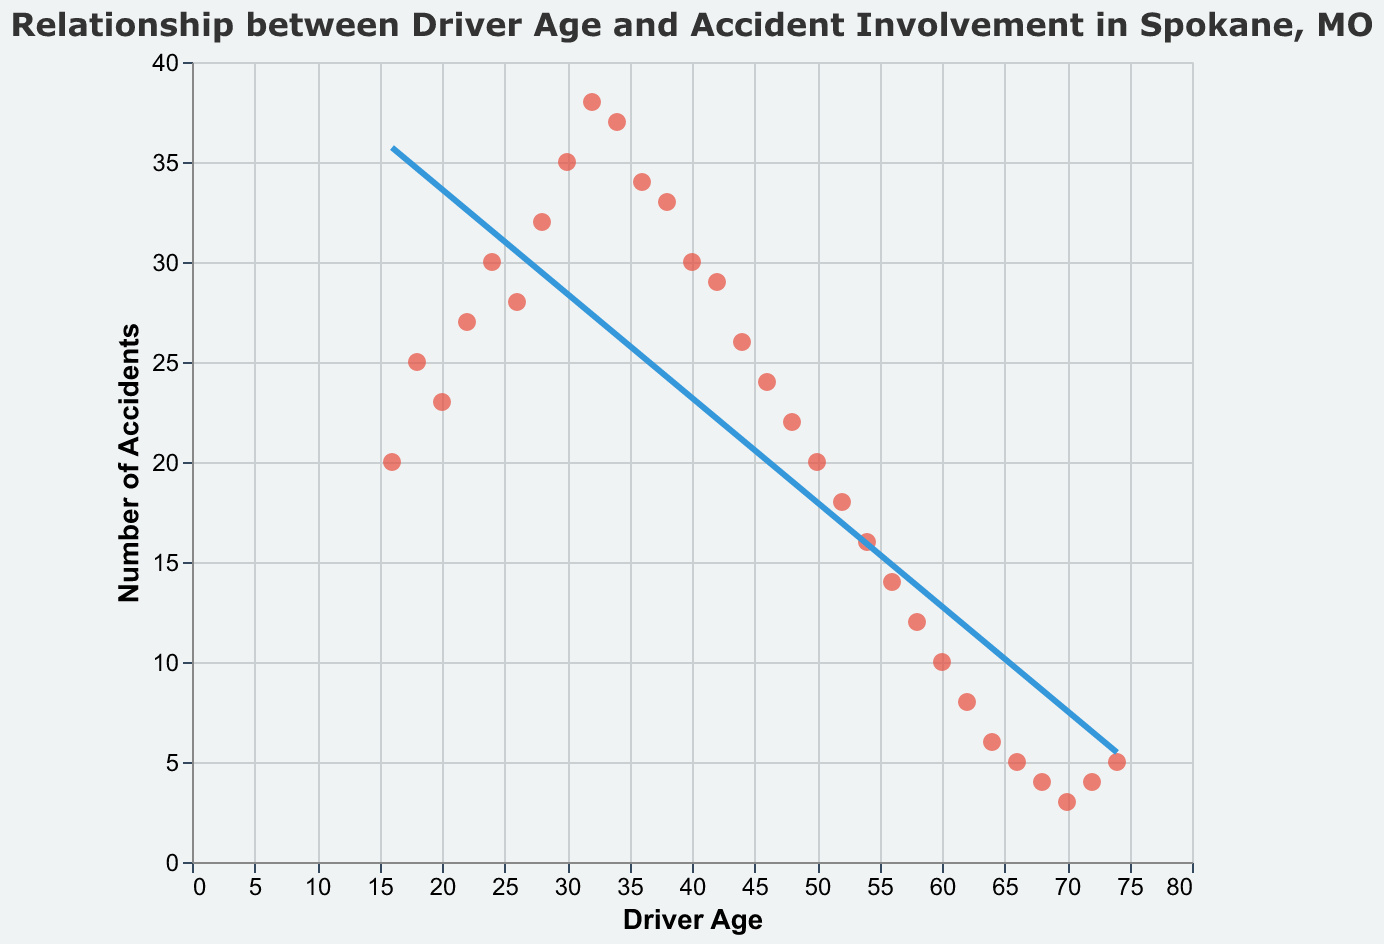What's the title of the scatter plot? The title is always displayed at the top of the figure. Here, it reads "Relationship between Driver Age and Accident Involvement in Spokane, MO".
Answer: Relationship between Driver Age and Accident Involvement in Spokane, MO How many data points are plotted in this scatter plot? To determine the number of data points, count each point individually or check the number of entries in the data. We have 30 driver age and accident count pairs, so there are 30 data points plotted.
Answer: 30 What is the y-axis title? The title of the y-axis is displayed alongside the vertical axis. Here, it reads "Number of Accidents".
Answer: Number of Accidents What is the range of the x-axis? The range of the x-axis is determined by the minimum and maximum values displayed. Here, the driver ages plotted range from 16 to 74.
Answer: 16 to 74 At what driver age does the highest number of accidents occur, and what is that number? To find this, identify the point with the highest y-value (accident count). The highest number of accidents is 38, which occurs at driver age 32.
Answer: 32, 38 Identify the trend in accident count as driver age increases. The trend line shows the general direction of the data. Here, the trend line decreases, indicating accident counts tend to decrease as driver age increases.
Answer: Decreases How many accidents were reported for driver age 70? Find the point where Driver Age is 70 and note the corresponding y-value (accident count). The count is 3 accidents.
Answer: 3 What is the average number of accidents for drivers aged between 50 and 60? Look at the accident counts for ages 50, 52, 54, 56, 58, and 60, then calculate their average: (20 + 18 + 16 + 14 + 12 + 10) / 6 = 15.
Answer: 15 Which driver age group has a surprisingly high accident count compared to the general trend? Look for anomalies in the scatter plot relative to the trend line. Drivers aged 18 and 32 both stand out. Age 32 has the highest count of 38, which is notably higher compared to surrounding ages.
Answer: 18, 32 Between drivers aged 34 and 50, which age has the highest number of accidents? From age 34 to age 50, compare the accident counts: 34 (37), 36 (34), 38 (33), 40 (30), 42 (29), 44 (26), 46 (24), 48 (22), 50 (20). Age 34 has the highest number with 37 accidents.
Answer: 34 